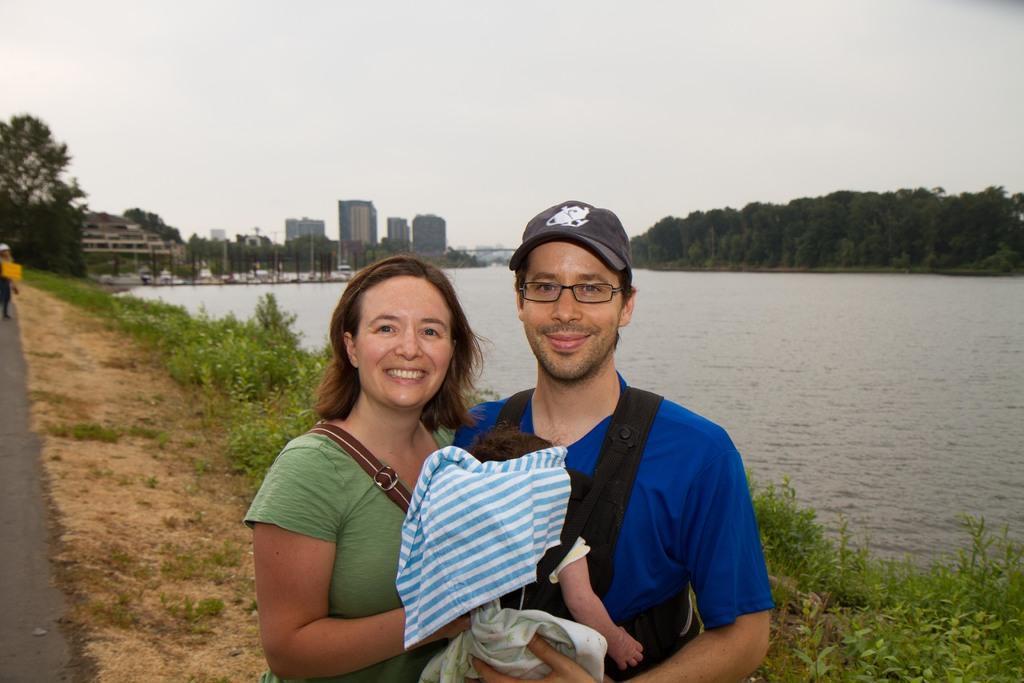Please provide a concise description of this image. In the picture I can see a person wearing blue T-shirt is carrying a baby and there is a woman beside him placed one of her hand on the baby and there are few plants behind them and there is water,buildings and trees in the background. 